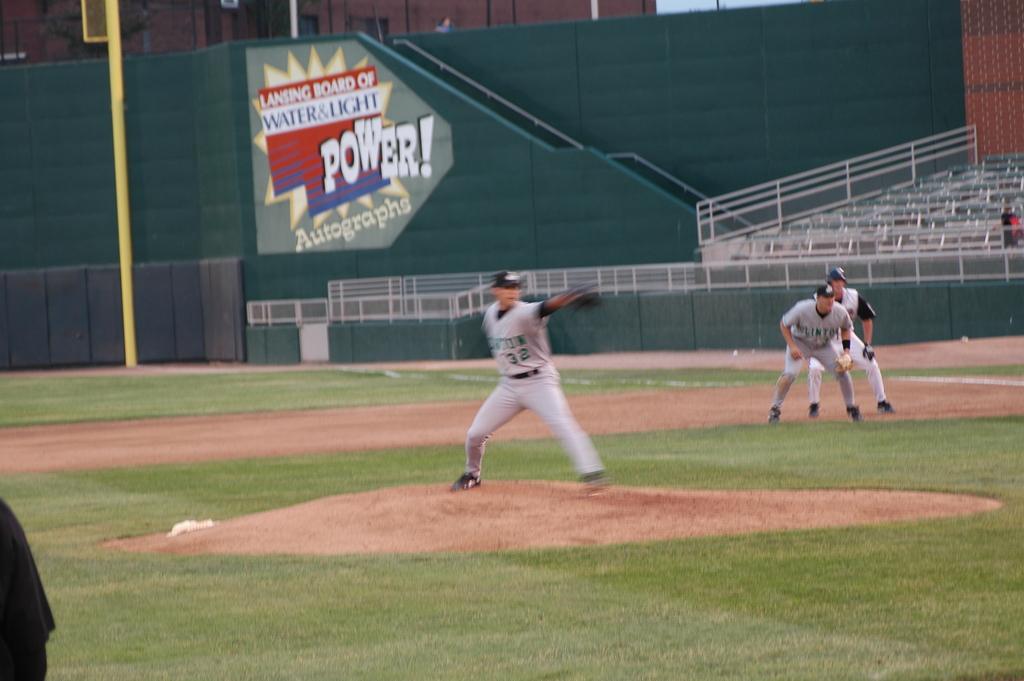What type of autographs?
Your response must be concise. Power. What number is the pitcher?
Provide a succinct answer. 32. 